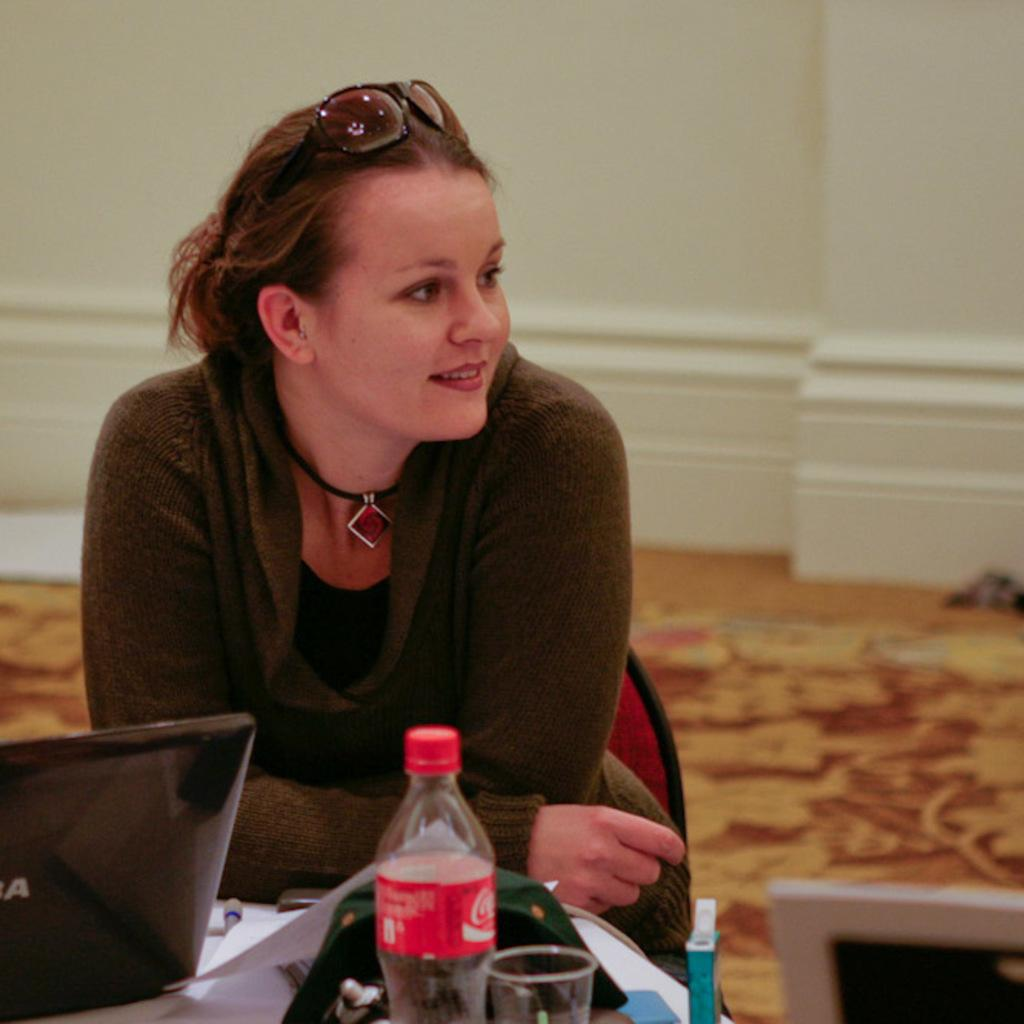Who is the main subject in the picture? There is a woman in the picture. What is the woman doing in the image? The woman is standing and smiling. What direction is the woman looking in the image? The woman is looking at her side. What objects are in front of the woman? The woman has a laptop and a beverage bottle in front of her. What type of turkey can be seen flying in the background of the image? There is no turkey present in the image, and therefore no such activity can be observed. 